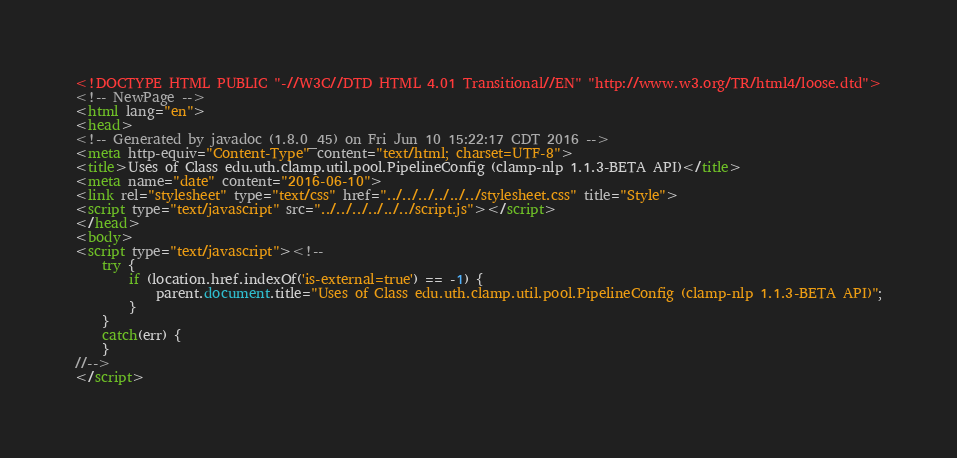<code> <loc_0><loc_0><loc_500><loc_500><_HTML_><!DOCTYPE HTML PUBLIC "-//W3C//DTD HTML 4.01 Transitional//EN" "http://www.w3.org/TR/html4/loose.dtd">
<!-- NewPage -->
<html lang="en">
<head>
<!-- Generated by javadoc (1.8.0_45) on Fri Jun 10 15:22:17 CDT 2016 -->
<meta http-equiv="Content-Type" content="text/html; charset=UTF-8">
<title>Uses of Class edu.uth.clamp.util.pool.PipelineConfig (clamp-nlp 1.1.3-BETA API)</title>
<meta name="date" content="2016-06-10">
<link rel="stylesheet" type="text/css" href="../../../../../../stylesheet.css" title="Style">
<script type="text/javascript" src="../../../../../../script.js"></script>
</head>
<body>
<script type="text/javascript"><!--
    try {
        if (location.href.indexOf('is-external=true') == -1) {
            parent.document.title="Uses of Class edu.uth.clamp.util.pool.PipelineConfig (clamp-nlp 1.1.3-BETA API)";
        }
    }
    catch(err) {
    }
//-->
</script></code> 